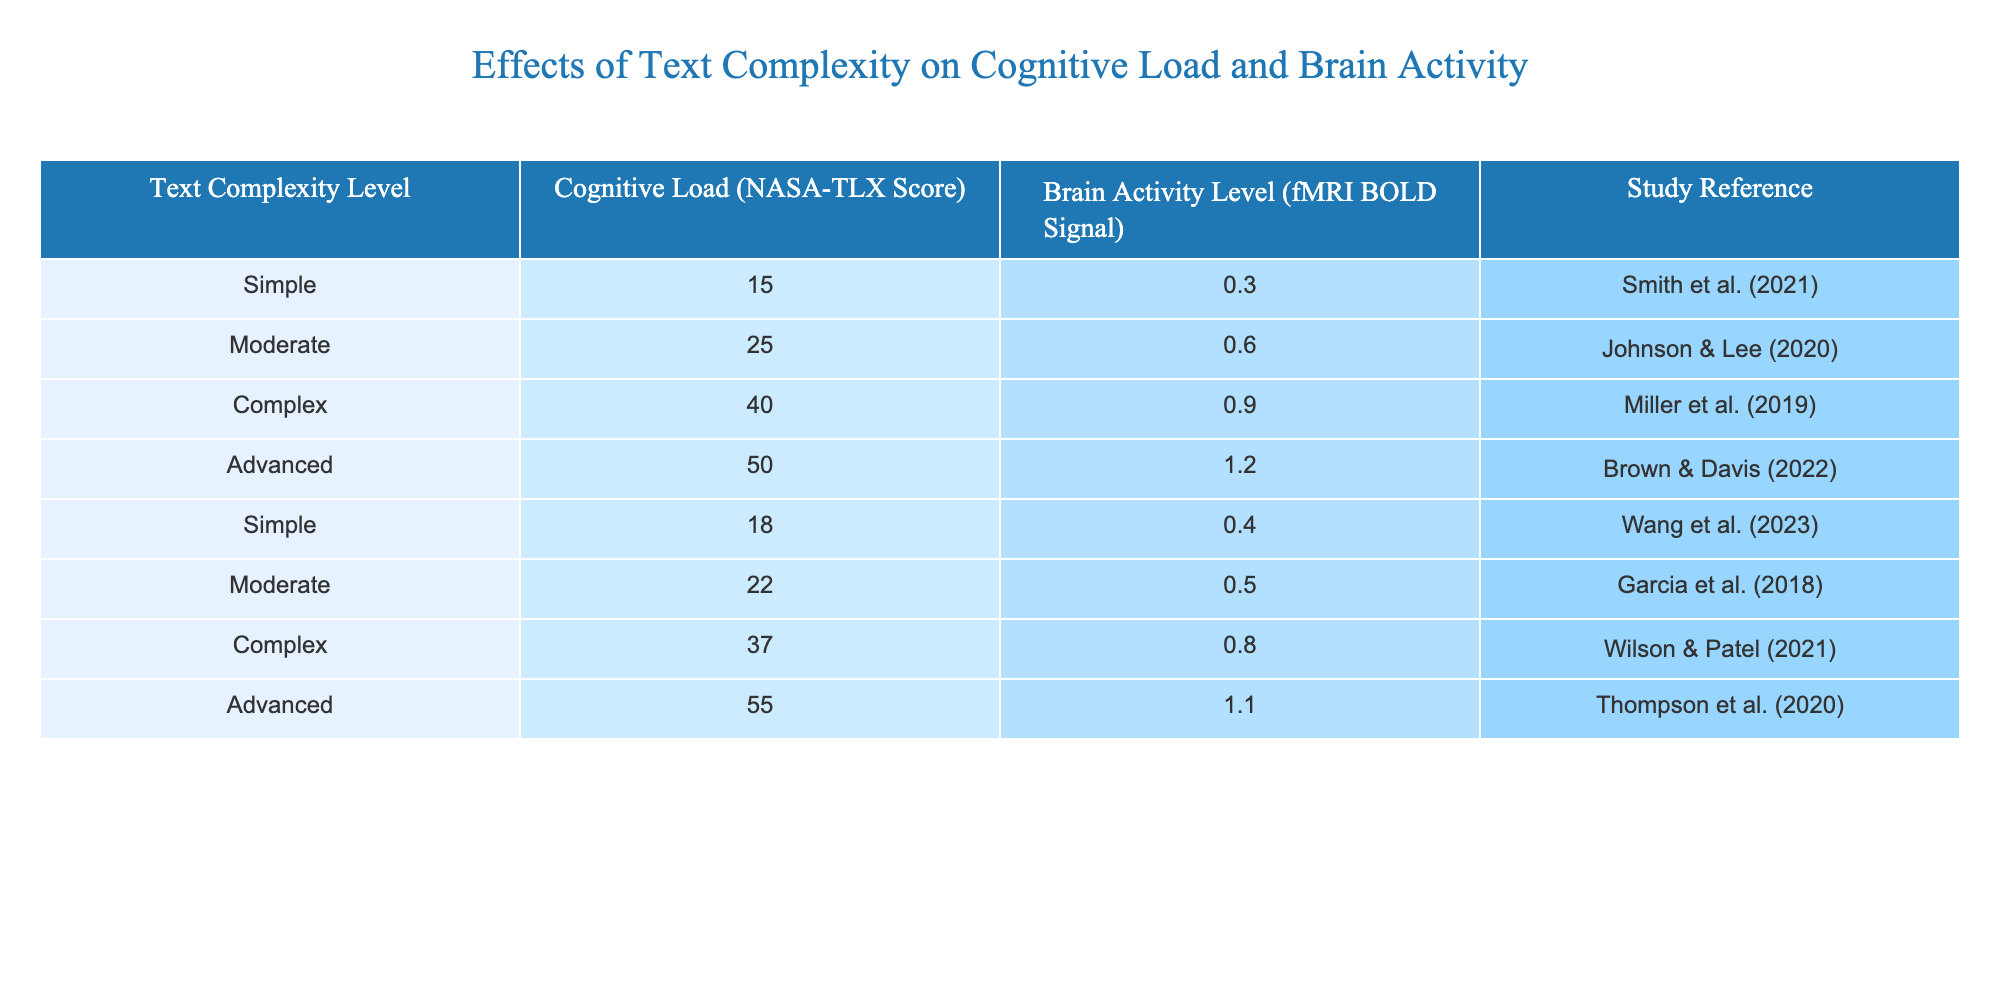What is the NASA-TLX score for the Advanced text complexity level? The table indicates that the Advanced text complexity level has a NASA-TLX score of 50, which is listed directly in the corresponding row.
Answer: 50 Which text complexity level has the highest brain activity level? By comparing the Brain Activity Level column, the Advanced complexity level shows the highest brain activity with a BOLD signal of 1.2, as per the values provided.
Answer: Advanced What is the average NASA-TLX score for Simple text complexity? There are two entries for Simple text complexity: 15 and 18. Adding these gives a sum of 33. There are 2 entries, so the average is 33/2 = 16.5.
Answer: 16.5 Is it true that Complex text complexity has a higher NASA-TLX score than Moderate text complexity? The NASA-TLX score for Complex is 40, while for Moderate it is 25. Since 40 is greater than 25, the statement is true.
Answer: Yes What is the difference in brain activity level between Complex and Advanced text complexity levels? The brain activity level for Complex is 0.9, and for Advanced, it is 1.2. The difference is 1.2 - 0.9 = 0.3.
Answer: 0.3 What is the total cognitive load score for all text complexity levels listed in the table? To find the total, we add all cognitive load scores: 15 + 25 + 40 + 50 + 18 + 22 + 37 + 55 = 212.
Answer: 212 Does the analysis show that all Advanced complexity studies report a similar brain activity level? The Advanced text complexity levels report two different brain activity scores (1.2 from Brown & Davis and 1.1 from Thompson et al.), indicating variability in the brain activity levels across different studies.
Answer: No Which text complexity level has the lowest cognitive load score? By inspecting the NASA-TLX scores, Simple complexity has the lowest score of 15, as seen in the table entries.
Answer: Simple 